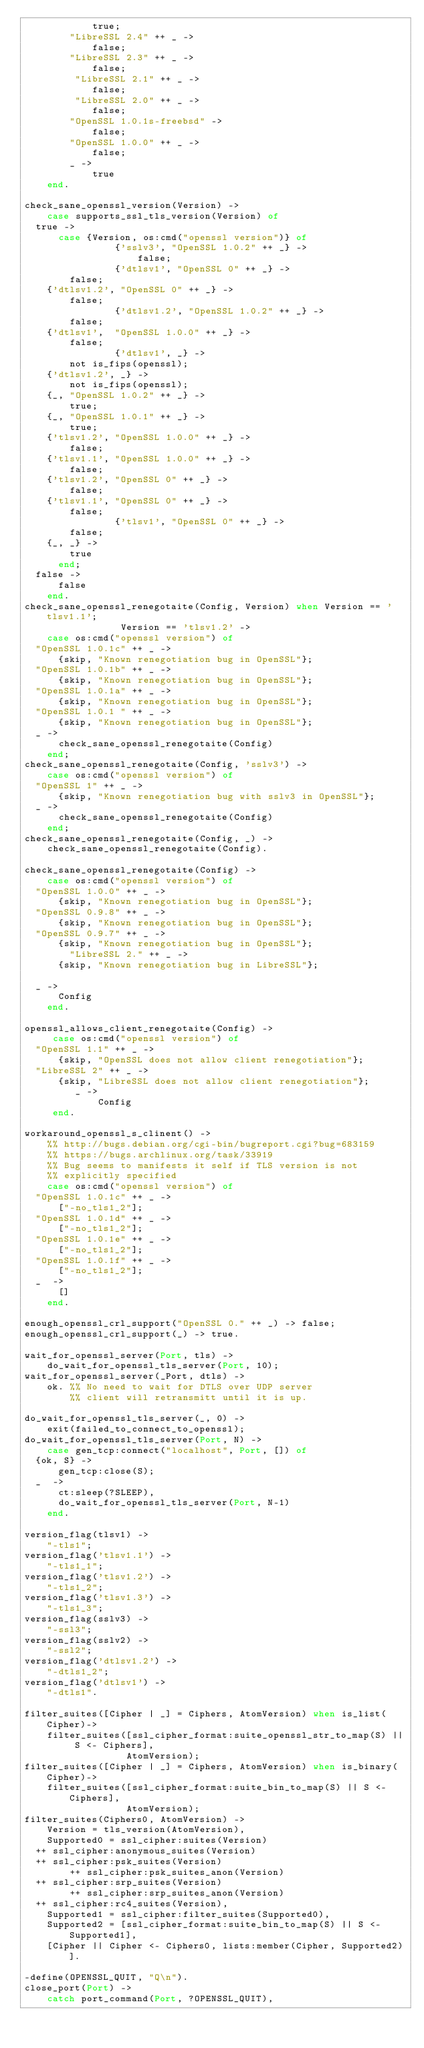<code> <loc_0><loc_0><loc_500><loc_500><_Erlang_>            true;
        "LibreSSL 2.4" ++ _ ->
            false;
        "LibreSSL 2.3" ++ _ ->
            false; 
         "LibreSSL 2.1" ++ _ ->
            false; 
         "LibreSSL 2.0" ++ _ ->
            false; 
        "OpenSSL 1.0.1s-freebsd" ->
            false;
        "OpenSSL 1.0.0" ++ _ ->
            false; 
        _ ->
            true
    end.

check_sane_openssl_version(Version) ->
    case supports_ssl_tls_version(Version) of 
	true ->
	    case {Version, os:cmd("openssl version")} of
                {'sslv3', "OpenSSL 1.0.2" ++ _} ->
                    false;
                {'dtlsv1', "OpenSSL 0" ++ _} ->
		    false;
		{'dtlsv1.2', "OpenSSL 0" ++ _} ->
		    false;
                {'dtlsv1.2', "OpenSSL 1.0.2" ++ _} ->
		    false;
		{'dtlsv1',  "OpenSSL 1.0.0" ++ _} ->
		    false;
                {'dtlsv1', _} ->
		    not is_fips(openssl);
		{'dtlsv1.2', _} ->
		    not is_fips(openssl);
		{_, "OpenSSL 1.0.2" ++ _} ->
		    true;
		{_, "OpenSSL 1.0.1" ++ _} ->
		    true;
		{'tlsv1.2', "OpenSSL 1.0.0" ++ _} ->
		    false;
		{'tlsv1.1', "OpenSSL 1.0.0" ++ _} ->
		    false;
		{'tlsv1.2', "OpenSSL 0" ++ _} ->
		    false;
		{'tlsv1.1', "OpenSSL 0" ++ _} ->
		    false;
                {'tlsv1', "OpenSSL 0" ++ _} ->
		    false;
		{_, _} ->
		    true
	    end;
	false ->
	    false
    end.
check_sane_openssl_renegotaite(Config, Version) when Version == 'tlsv1.1';
						     Version == 'tlsv1.2' ->
    case os:cmd("openssl version") of     
	"OpenSSL 1.0.1c" ++ _ ->
	    {skip, "Known renegotiation bug in OpenSSL"};
	"OpenSSL 1.0.1b" ++ _ ->
	    {skip, "Known renegotiation bug in OpenSSL"};
	"OpenSSL 1.0.1a" ++ _ ->
	    {skip, "Known renegotiation bug in OpenSSL"};
	"OpenSSL 1.0.1 " ++ _ ->
	    {skip, "Known renegotiation bug in OpenSSL"};
	_ ->
	    check_sane_openssl_renegotaite(Config)
    end;
check_sane_openssl_renegotaite(Config, 'sslv3') ->
    case os:cmd("openssl version") of     
	"OpenSSL 1" ++ _ ->
	    {skip, "Known renegotiation bug with sslv3 in OpenSSL"};
	_ ->
	    check_sane_openssl_renegotaite(Config)
    end;
check_sane_openssl_renegotaite(Config, _) ->
    check_sane_openssl_renegotaite(Config).
	
check_sane_openssl_renegotaite(Config) ->
    case os:cmd("openssl version") of  
	"OpenSSL 1.0.0" ++ _ ->
	    {skip, "Known renegotiation bug in OpenSSL"};
	"OpenSSL 0.9.8" ++ _ ->
	    {skip, "Known renegotiation bug in OpenSSL"};
	"OpenSSL 0.9.7" ++ _ ->
	    {skip, "Known renegotiation bug in OpenSSL"};
        "LibreSSL 2." ++ _ ->
	    {skip, "Known renegotiation bug in LibreSSL"};
        
	_ ->
	    Config
    end.

openssl_allows_client_renegotaite(Config) ->
     case os:cmd("openssl version") of  
	"OpenSSL 1.1" ++ _ ->
	    {skip, "OpenSSL does not allow client renegotiation"};
	"LibreSSL 2" ++ _ ->
	    {skip, "LibreSSL does not allow client renegotiation"};
         _ ->
             Config
     end.

workaround_openssl_s_clinent() ->
    %% http://bugs.debian.org/cgi-bin/bugreport.cgi?bug=683159
    %% https://bugs.archlinux.org/task/33919
    %% Bug seems to manifests it self if TLS version is not
    %% explicitly specified 
    case os:cmd("openssl version") of 
	"OpenSSL 1.0.1c" ++ _ ->
	    ["-no_tls1_2"];
	"OpenSSL 1.0.1d" ++ _ ->
	    ["-no_tls1_2"];
	"OpenSSL 1.0.1e" ++ _ ->
	    ["-no_tls1_2"];
	"OpenSSL 1.0.1f" ++ _ ->
	    ["-no_tls1_2"];
	_  ->
	    []
    end.

enough_openssl_crl_support("OpenSSL 0." ++ _) -> false;
enough_openssl_crl_support(_) -> true.

wait_for_openssl_server(Port, tls) ->
    do_wait_for_openssl_tls_server(Port, 10);
wait_for_openssl_server(_Port, dtls) ->
    ok. %% No need to wait for DTLS over UDP server
        %% client will retransmitt until it is up.

do_wait_for_openssl_tls_server(_, 0) ->
    exit(failed_to_connect_to_openssl);
do_wait_for_openssl_tls_server(Port, N) ->
    case gen_tcp:connect("localhost", Port, []) of
	{ok, S} ->
	    gen_tcp:close(S);
	_  ->
	    ct:sleep(?SLEEP),
	    do_wait_for_openssl_tls_server(Port, N-1)
    end.

version_flag(tlsv1) ->
    "-tls1";
version_flag('tlsv1.1') ->
    "-tls1_1";
version_flag('tlsv1.2') ->
    "-tls1_2";
version_flag('tlsv1.3') ->
    "-tls1_3";
version_flag(sslv3) ->
    "-ssl3";
version_flag(sslv2) ->
    "-ssl2";
version_flag('dtlsv1.2') ->
    "-dtls1_2";
version_flag('dtlsv1') ->
    "-dtls1".

filter_suites([Cipher | _] = Ciphers, AtomVersion) when is_list(Cipher)->
    filter_suites([ssl_cipher_format:suite_openssl_str_to_map(S) || S <- Ciphers], 
                  AtomVersion);
filter_suites([Cipher | _] = Ciphers, AtomVersion) when is_binary(Cipher)->
    filter_suites([ssl_cipher_format:suite_bin_to_map(S) || S <- Ciphers], 
                  AtomVersion);
filter_suites(Ciphers0, AtomVersion) ->
    Version = tls_version(AtomVersion),
    Supported0 = ssl_cipher:suites(Version)
	++ ssl_cipher:anonymous_suites(Version)
	++ ssl_cipher:psk_suites(Version)
        ++ ssl_cipher:psk_suites_anon(Version)
	++ ssl_cipher:srp_suites(Version) 
        ++ ssl_cipher:srp_suites_anon(Version) 
	++ ssl_cipher:rc4_suites(Version),
    Supported1 = ssl_cipher:filter_suites(Supported0),
    Supported2 = [ssl_cipher_format:suite_bin_to_map(S) || S <- Supported1],
    [Cipher || Cipher <- Ciphers0, lists:member(Cipher, Supported2)].

-define(OPENSSL_QUIT, "Q\n").
close_port(Port) ->
    catch port_command(Port, ?OPENSSL_QUIT),</code> 